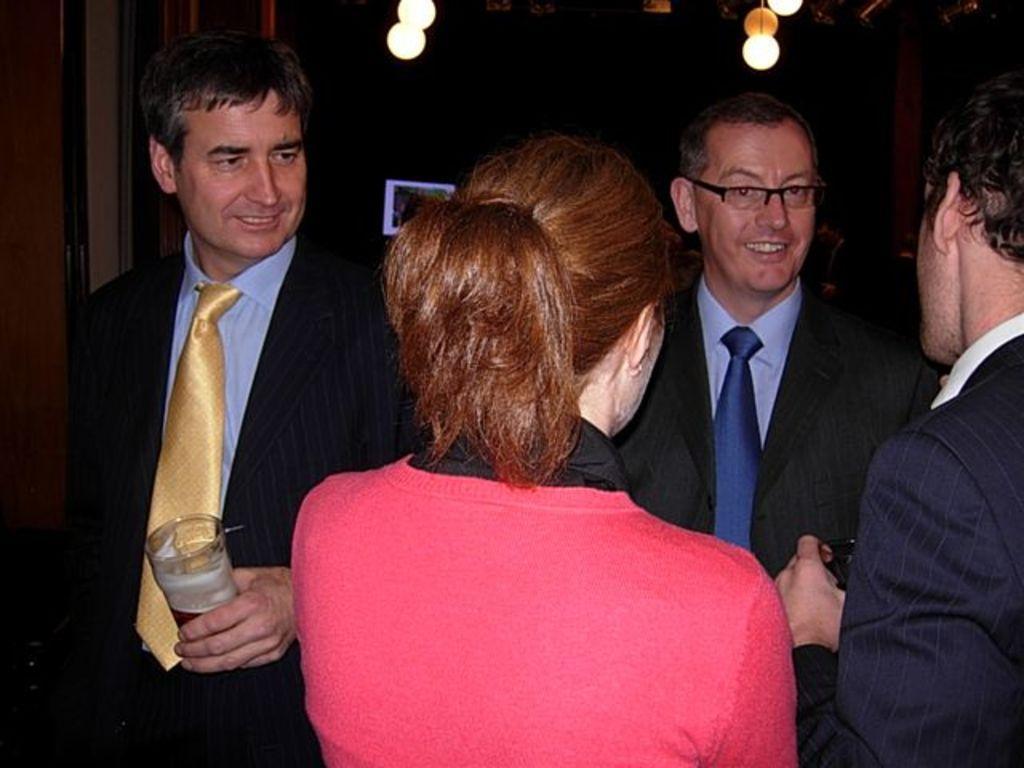Can you describe this image briefly? In this image I can see group of people standing. In front the person is wearing black and pink color dress and the person at left is holding the glass. Background I can see few lights. 